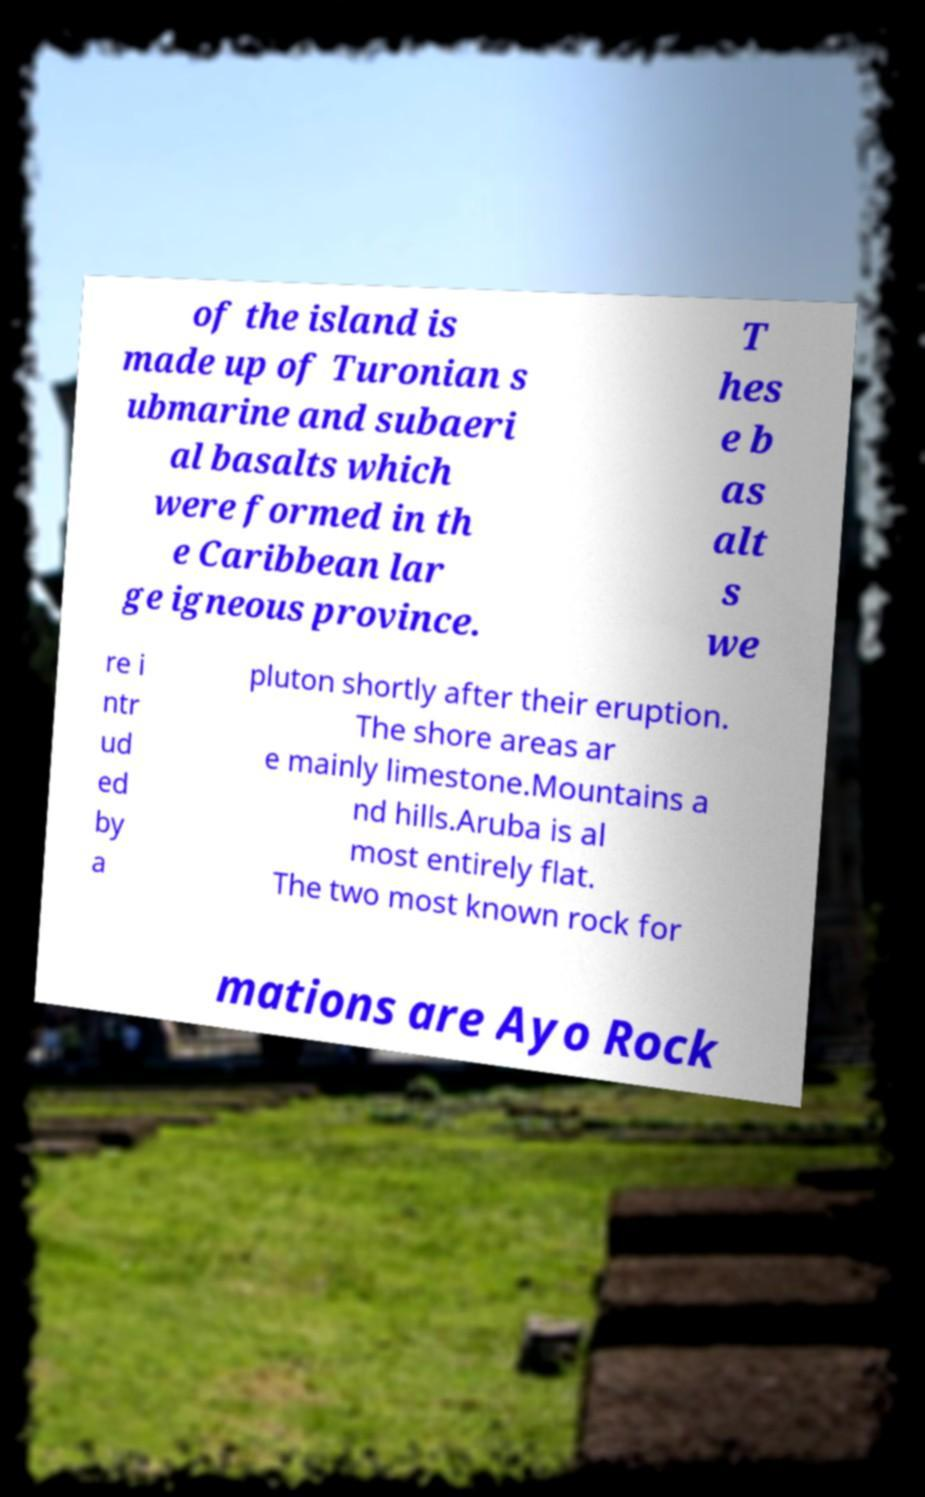Could you extract and type out the text from this image? of the island is made up of Turonian s ubmarine and subaeri al basalts which were formed in th e Caribbean lar ge igneous province. T hes e b as alt s we re i ntr ud ed by a pluton shortly after their eruption. The shore areas ar e mainly limestone.Mountains a nd hills.Aruba is al most entirely flat. The two most known rock for mations are Ayo Rock 